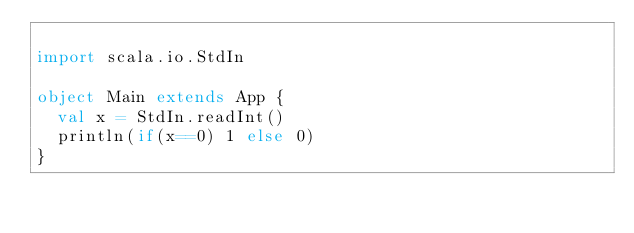<code> <loc_0><loc_0><loc_500><loc_500><_Scala_>
import scala.io.StdIn

object Main extends App {
  val x = StdIn.readInt()
  println(if(x==0) 1 else 0)
}





</code> 